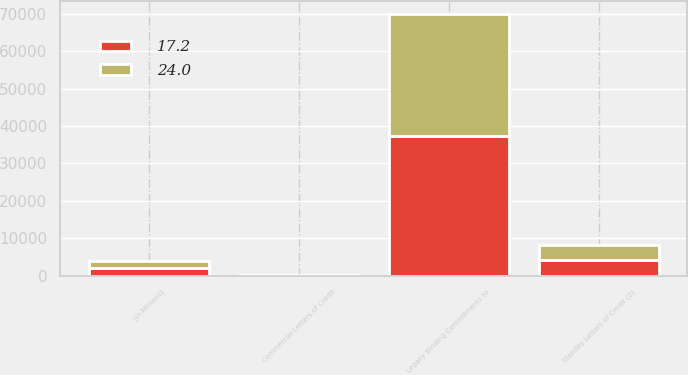Convert chart to OTSL. <chart><loc_0><loc_0><loc_500><loc_500><stacked_bar_chart><ecel><fcel>(In Millions)<fcel>Legally Binding Commitments to<fcel>Standby Letters of Credit (2)<fcel>Commercial Letters of Credit<nl><fcel>24<fcel>2016<fcel>32768.1<fcel>3846.1<fcel>24<nl><fcel>17.2<fcel>2015<fcel>37247<fcel>4305.4<fcel>17.2<nl></chart> 